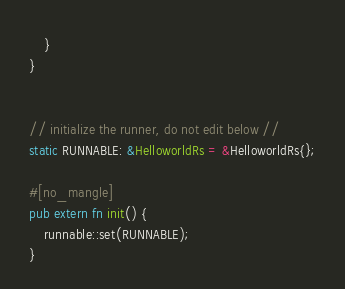Convert code to text. <code><loc_0><loc_0><loc_500><loc_500><_Rust_>    }
}


// initialize the runner, do not edit below //
static RUNNABLE: &HelloworldRs = &HelloworldRs{};

#[no_mangle]
pub extern fn init() {
    runnable::set(RUNNABLE);
}
</code> 